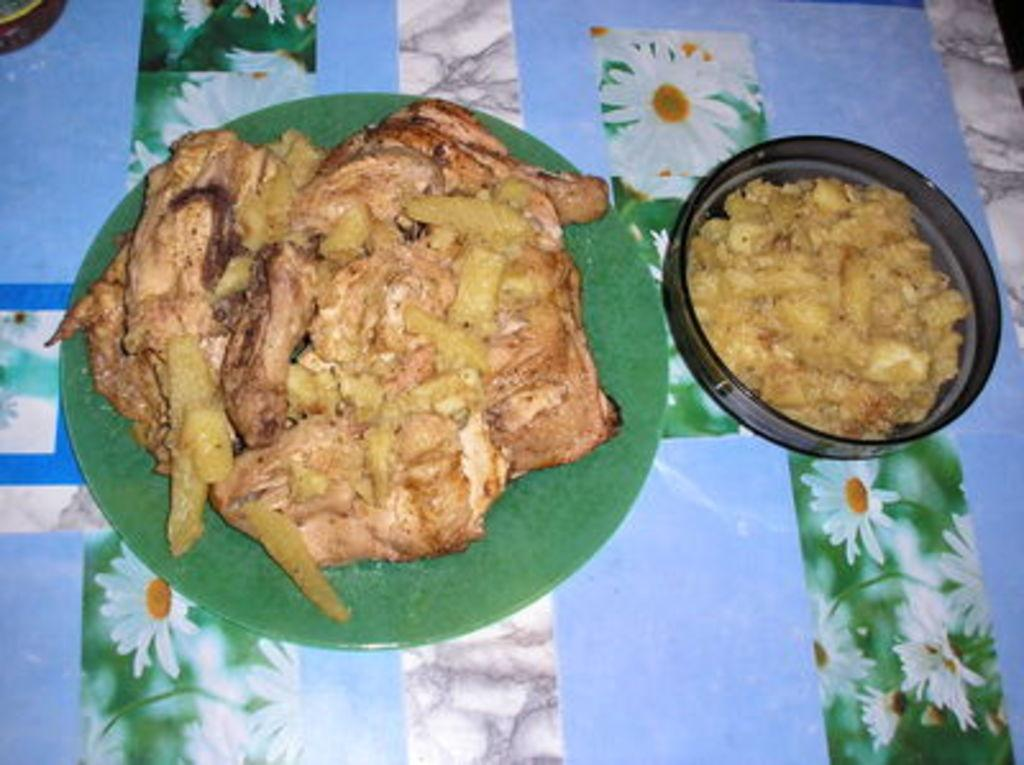What piece of furniture is present in the image? There is a table in the image. What is placed on the table? There are plates on the table. What can be found on the plates? There is a food item on the plate. What type of wine is being served with the food in the image? There is no wine present in the image; only a table, plates, and a food item are visible. 